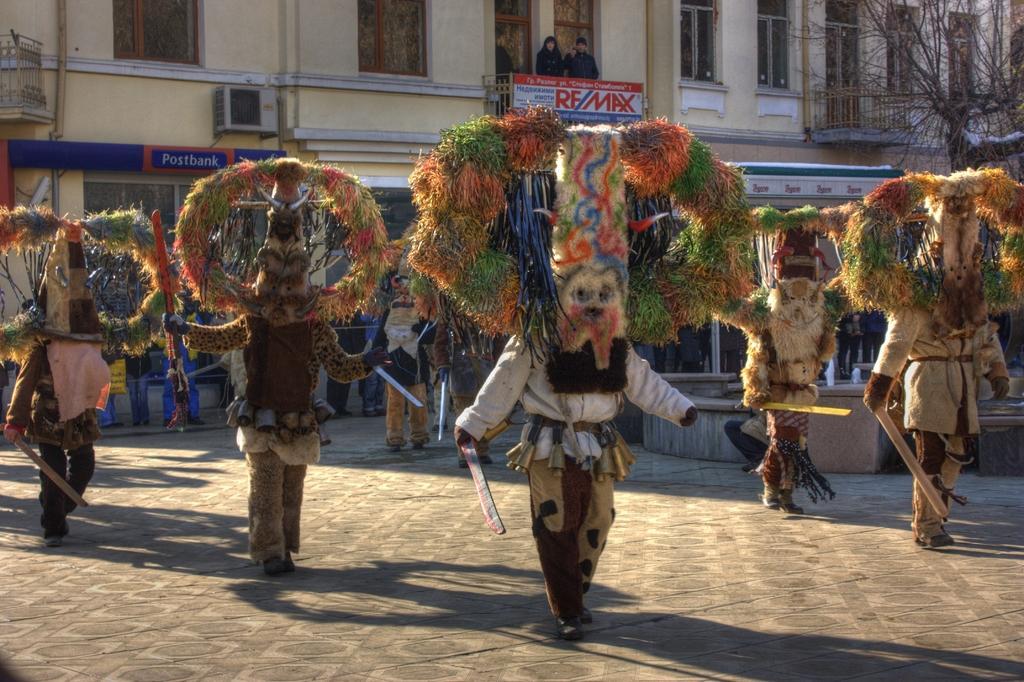Could you give a brief overview of what you see in this image? In this picture I can see there is a carnival, there are few people wearing special costumes and holding few objects in their hands there are few people standing in the backdrop, there is a building behind them and there are few people standing in the balcony and there is a tree on to right and there is some snow on the tree. 